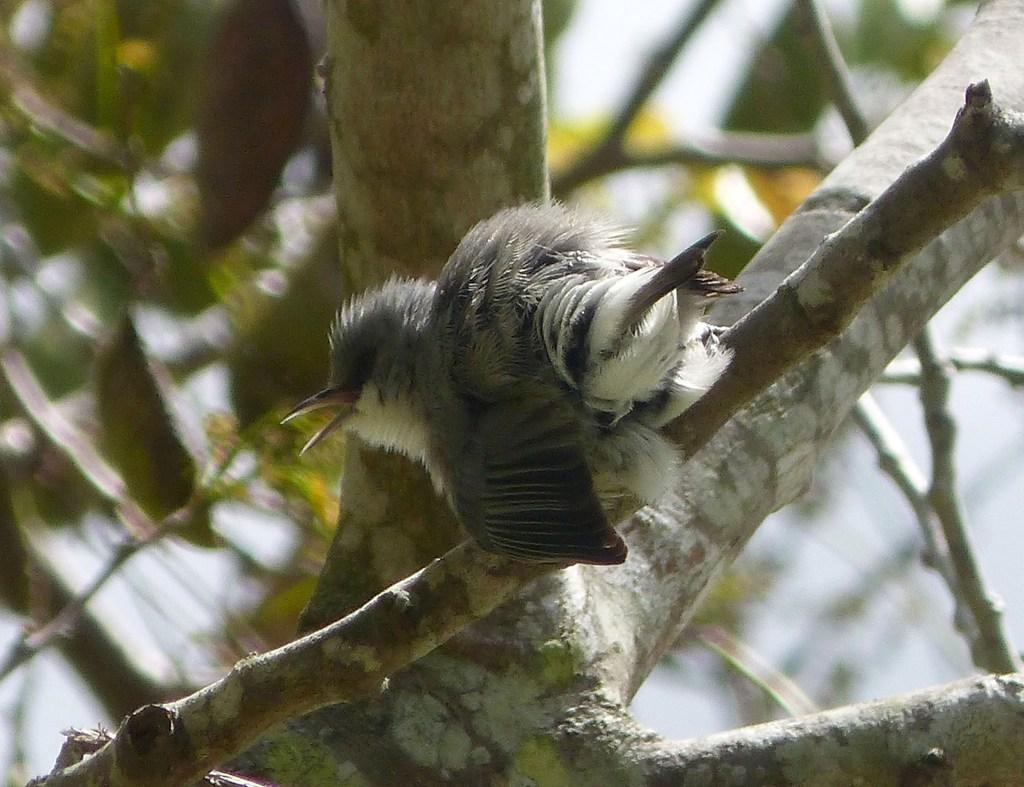What type of animal is in the image? There is a bird in the image. What color is the bird? The bird is grey in color. Where is the bird located in the image? The bird is on a branch of a tree. What type of vegetation is visible in the image? There are green leaves on the left side of the image. What type of leather is the stranger using to pay for their credit in the image? There is no stranger, leather, or credit present in the image; it features a grey bird on a tree branch with green leaves. 